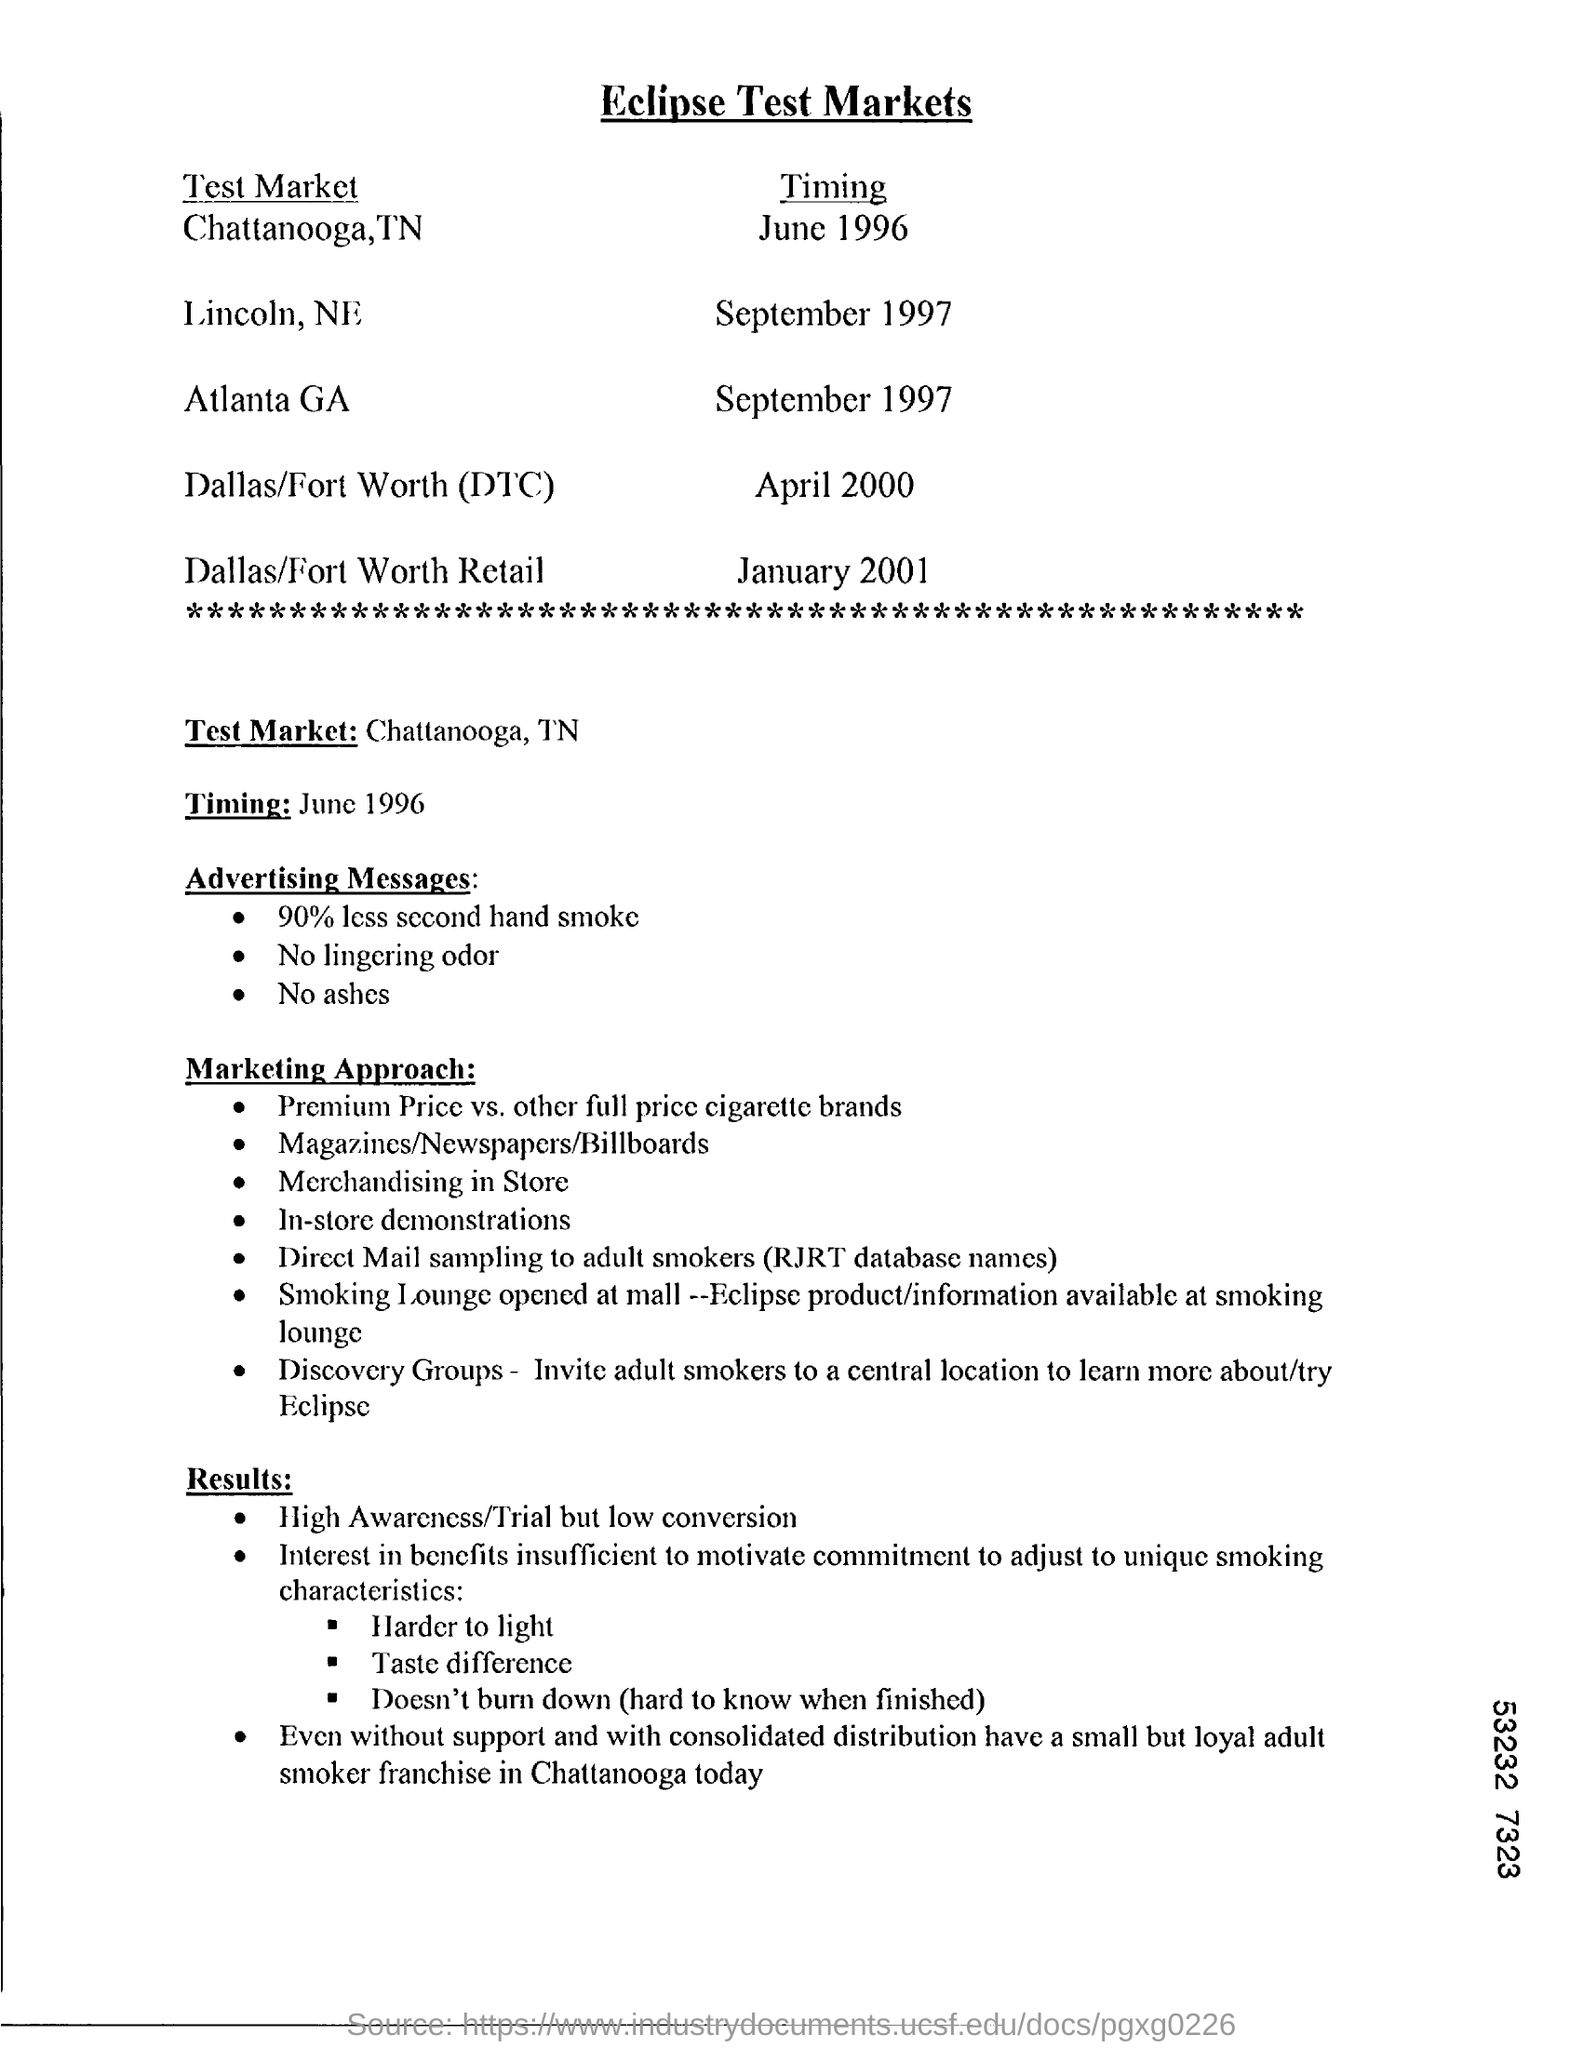Identify some key points in this picture. The timing for Atlanta, Georgia is scheduled for September 1997. The timing for Dallas/Fort Worth (DTC) was in April 2000. 